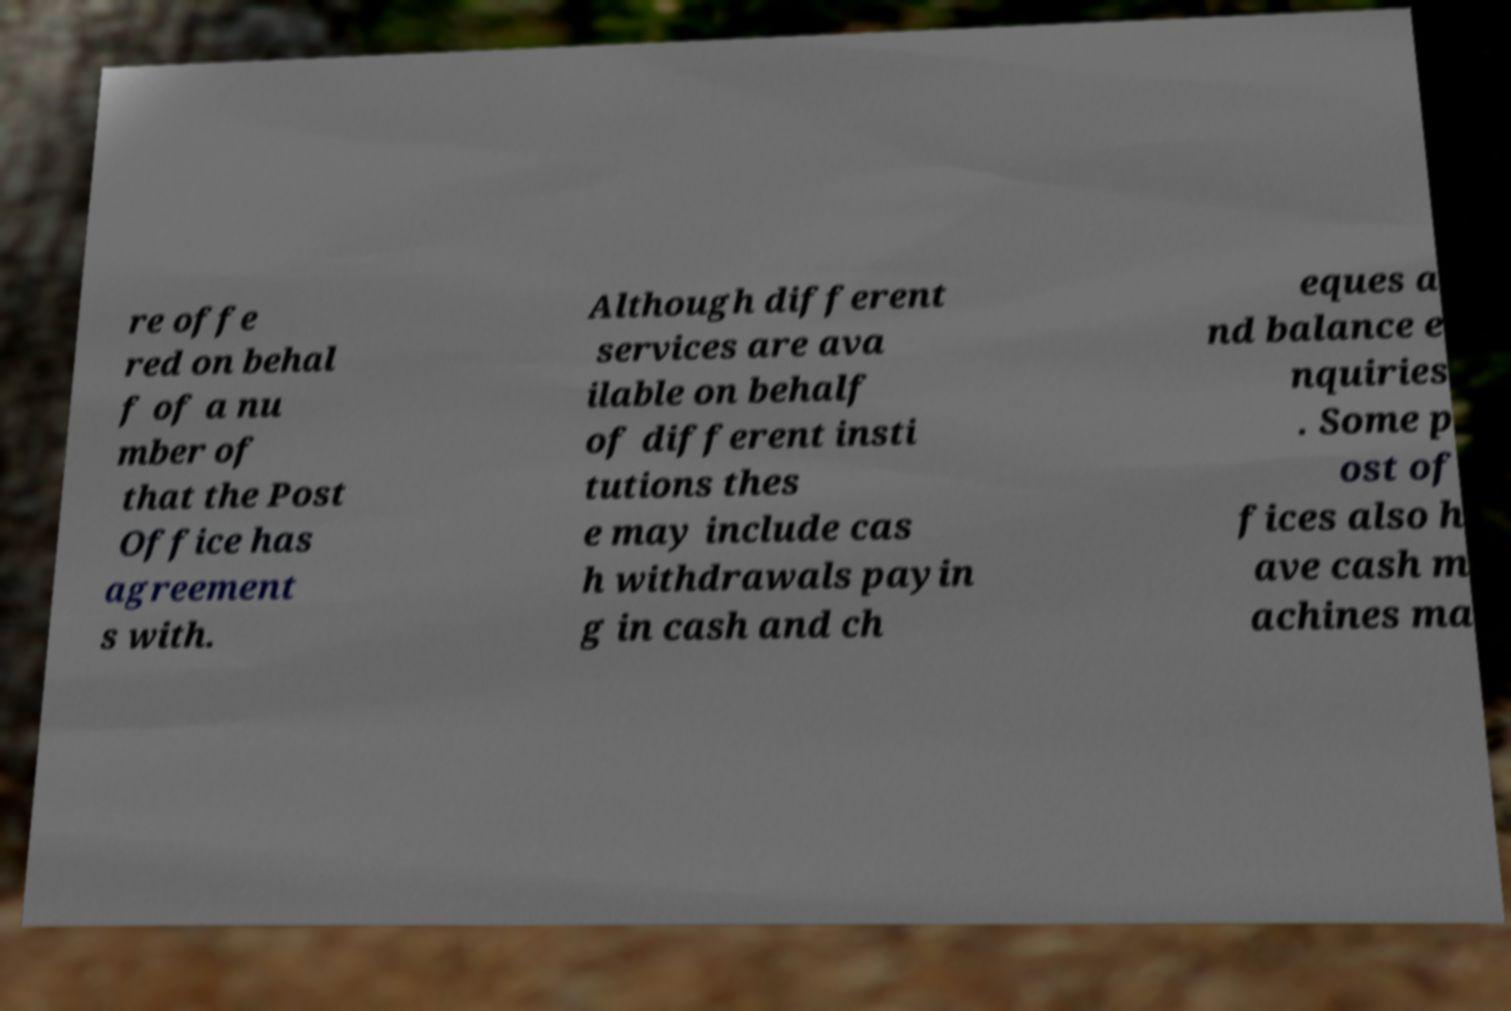Could you assist in decoding the text presented in this image and type it out clearly? re offe red on behal f of a nu mber of that the Post Office has agreement s with. Although different services are ava ilable on behalf of different insti tutions thes e may include cas h withdrawals payin g in cash and ch eques a nd balance e nquiries . Some p ost of fices also h ave cash m achines ma 